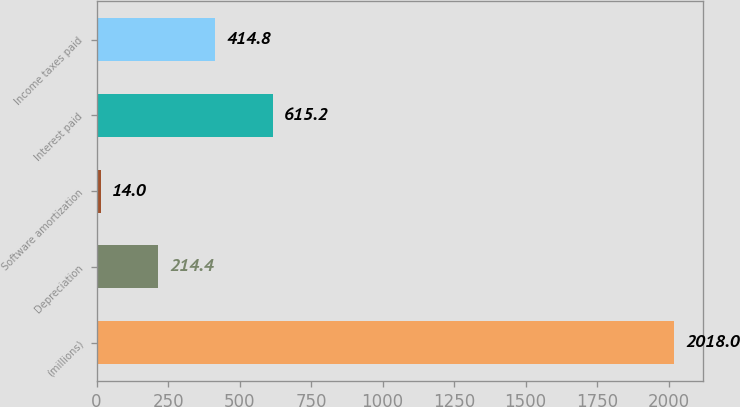Convert chart. <chart><loc_0><loc_0><loc_500><loc_500><bar_chart><fcel>(millions)<fcel>Depreciation<fcel>Software amortization<fcel>Interest paid<fcel>Income taxes paid<nl><fcel>2018<fcel>214.4<fcel>14<fcel>615.2<fcel>414.8<nl></chart> 